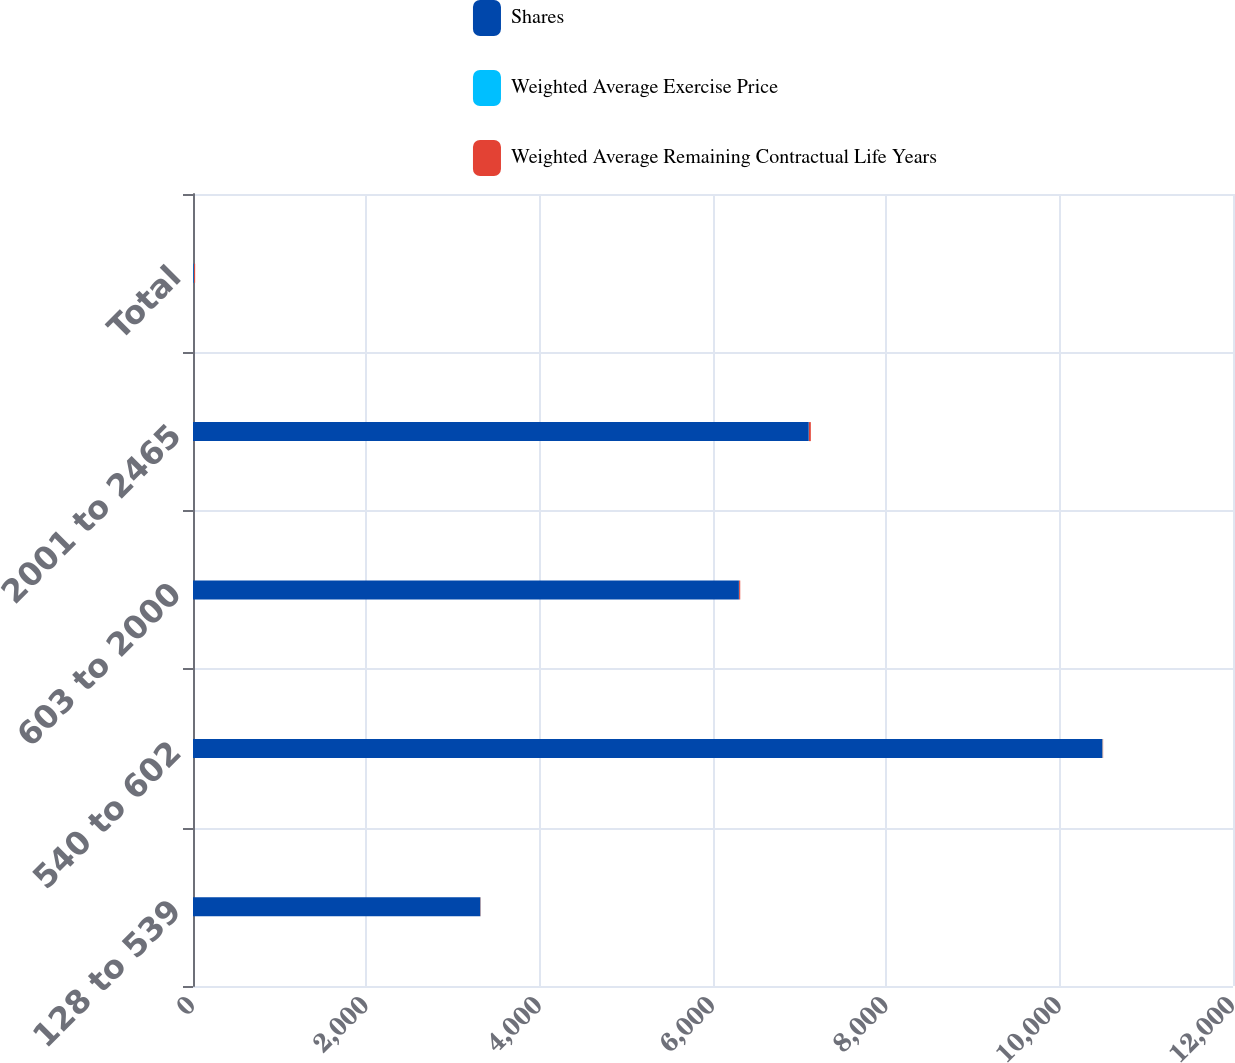<chart> <loc_0><loc_0><loc_500><loc_500><stacked_bar_chart><ecel><fcel>128 to 539<fcel>540 to 602<fcel>603 to 2000<fcel>2001 to 2465<fcel>Total<nl><fcel>Shares<fcel>3312<fcel>10489<fcel>6299<fcel>7105<fcel>8.985<nl><fcel>Weighted Average Exercise Price<fcel>4.8<fcel>6.5<fcel>2.8<fcel>1.6<fcel>4.2<nl><fcel>Weighted Average Remaining Contractual Life Years<fcel>4.42<fcel>6.01<fcel>12.34<fcel>22.03<fcel>11.47<nl></chart> 